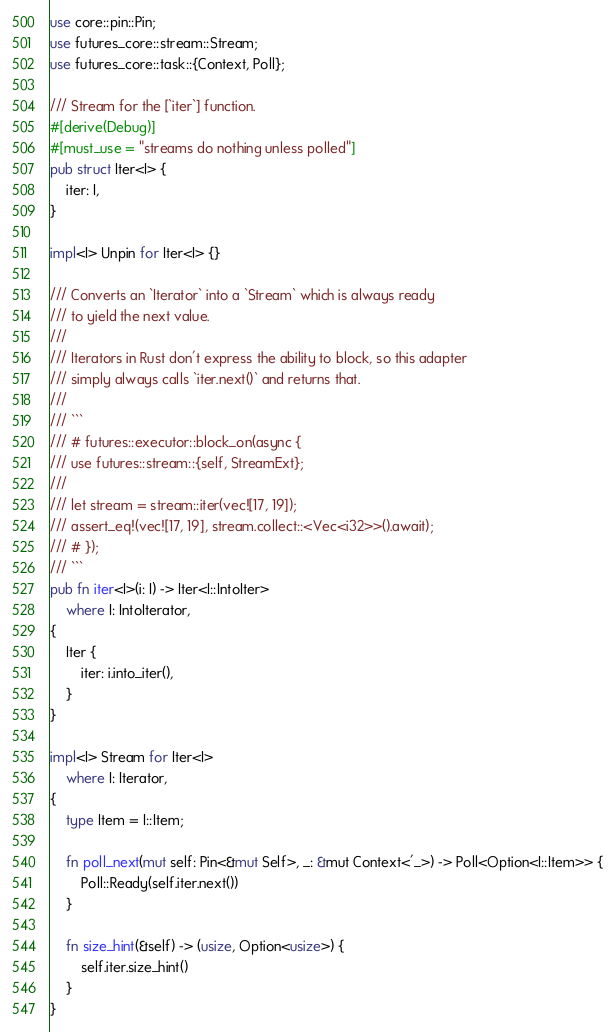Convert code to text. <code><loc_0><loc_0><loc_500><loc_500><_Rust_>use core::pin::Pin;
use futures_core::stream::Stream;
use futures_core::task::{Context, Poll};

/// Stream for the [`iter`] function.
#[derive(Debug)]
#[must_use = "streams do nothing unless polled"]
pub struct Iter<I> {
    iter: I,
}

impl<I> Unpin for Iter<I> {}

/// Converts an `Iterator` into a `Stream` which is always ready
/// to yield the next value.
///
/// Iterators in Rust don't express the ability to block, so this adapter
/// simply always calls `iter.next()` and returns that.
///
/// ```
/// # futures::executor::block_on(async {
/// use futures::stream::{self, StreamExt};
///
/// let stream = stream::iter(vec![17, 19]);
/// assert_eq!(vec![17, 19], stream.collect::<Vec<i32>>().await);
/// # });
/// ```
pub fn iter<I>(i: I) -> Iter<I::IntoIter>
    where I: IntoIterator,
{
    Iter {
        iter: i.into_iter(),
    }
}

impl<I> Stream for Iter<I>
    where I: Iterator,
{
    type Item = I::Item;

    fn poll_next(mut self: Pin<&mut Self>, _: &mut Context<'_>) -> Poll<Option<I::Item>> {
        Poll::Ready(self.iter.next())
    }

    fn size_hint(&self) -> (usize, Option<usize>) {
        self.iter.size_hint()
    }
}
</code> 